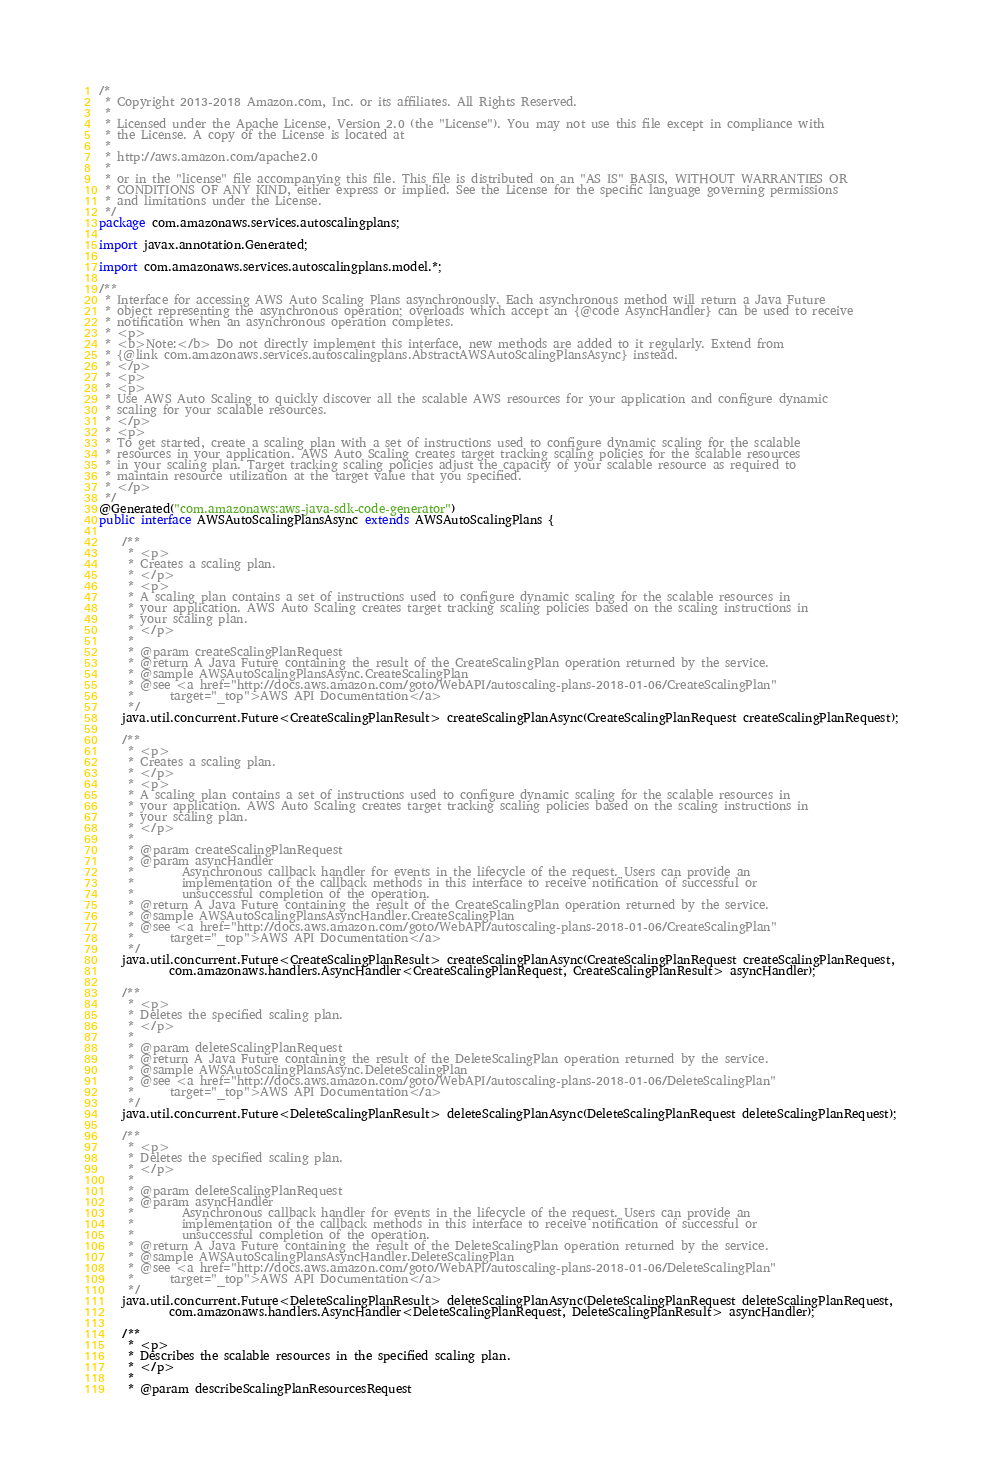<code> <loc_0><loc_0><loc_500><loc_500><_Java_>/*
 * Copyright 2013-2018 Amazon.com, Inc. or its affiliates. All Rights Reserved.
 * 
 * Licensed under the Apache License, Version 2.0 (the "License"). You may not use this file except in compliance with
 * the License. A copy of the License is located at
 * 
 * http://aws.amazon.com/apache2.0
 * 
 * or in the "license" file accompanying this file. This file is distributed on an "AS IS" BASIS, WITHOUT WARRANTIES OR
 * CONDITIONS OF ANY KIND, either express or implied. See the License for the specific language governing permissions
 * and limitations under the License.
 */
package com.amazonaws.services.autoscalingplans;

import javax.annotation.Generated;

import com.amazonaws.services.autoscalingplans.model.*;

/**
 * Interface for accessing AWS Auto Scaling Plans asynchronously. Each asynchronous method will return a Java Future
 * object representing the asynchronous operation; overloads which accept an {@code AsyncHandler} can be used to receive
 * notification when an asynchronous operation completes.
 * <p>
 * <b>Note:</b> Do not directly implement this interface, new methods are added to it regularly. Extend from
 * {@link com.amazonaws.services.autoscalingplans.AbstractAWSAutoScalingPlansAsync} instead.
 * </p>
 * <p>
 * <p>
 * Use AWS Auto Scaling to quickly discover all the scalable AWS resources for your application and configure dynamic
 * scaling for your scalable resources.
 * </p>
 * <p>
 * To get started, create a scaling plan with a set of instructions used to configure dynamic scaling for the scalable
 * resources in your application. AWS Auto Scaling creates target tracking scaling policies for the scalable resources
 * in your scaling plan. Target tracking scaling policies adjust the capacity of your scalable resource as required to
 * maintain resource utilization at the target value that you specified.
 * </p>
 */
@Generated("com.amazonaws:aws-java-sdk-code-generator")
public interface AWSAutoScalingPlansAsync extends AWSAutoScalingPlans {

    /**
     * <p>
     * Creates a scaling plan.
     * </p>
     * <p>
     * A scaling plan contains a set of instructions used to configure dynamic scaling for the scalable resources in
     * your application. AWS Auto Scaling creates target tracking scaling policies based on the scaling instructions in
     * your scaling plan.
     * </p>
     * 
     * @param createScalingPlanRequest
     * @return A Java Future containing the result of the CreateScalingPlan operation returned by the service.
     * @sample AWSAutoScalingPlansAsync.CreateScalingPlan
     * @see <a href="http://docs.aws.amazon.com/goto/WebAPI/autoscaling-plans-2018-01-06/CreateScalingPlan"
     *      target="_top">AWS API Documentation</a>
     */
    java.util.concurrent.Future<CreateScalingPlanResult> createScalingPlanAsync(CreateScalingPlanRequest createScalingPlanRequest);

    /**
     * <p>
     * Creates a scaling plan.
     * </p>
     * <p>
     * A scaling plan contains a set of instructions used to configure dynamic scaling for the scalable resources in
     * your application. AWS Auto Scaling creates target tracking scaling policies based on the scaling instructions in
     * your scaling plan.
     * </p>
     * 
     * @param createScalingPlanRequest
     * @param asyncHandler
     *        Asynchronous callback handler for events in the lifecycle of the request. Users can provide an
     *        implementation of the callback methods in this interface to receive notification of successful or
     *        unsuccessful completion of the operation.
     * @return A Java Future containing the result of the CreateScalingPlan operation returned by the service.
     * @sample AWSAutoScalingPlansAsyncHandler.CreateScalingPlan
     * @see <a href="http://docs.aws.amazon.com/goto/WebAPI/autoscaling-plans-2018-01-06/CreateScalingPlan"
     *      target="_top">AWS API Documentation</a>
     */
    java.util.concurrent.Future<CreateScalingPlanResult> createScalingPlanAsync(CreateScalingPlanRequest createScalingPlanRequest,
            com.amazonaws.handlers.AsyncHandler<CreateScalingPlanRequest, CreateScalingPlanResult> asyncHandler);

    /**
     * <p>
     * Deletes the specified scaling plan.
     * </p>
     * 
     * @param deleteScalingPlanRequest
     * @return A Java Future containing the result of the DeleteScalingPlan operation returned by the service.
     * @sample AWSAutoScalingPlansAsync.DeleteScalingPlan
     * @see <a href="http://docs.aws.amazon.com/goto/WebAPI/autoscaling-plans-2018-01-06/DeleteScalingPlan"
     *      target="_top">AWS API Documentation</a>
     */
    java.util.concurrent.Future<DeleteScalingPlanResult> deleteScalingPlanAsync(DeleteScalingPlanRequest deleteScalingPlanRequest);

    /**
     * <p>
     * Deletes the specified scaling plan.
     * </p>
     * 
     * @param deleteScalingPlanRequest
     * @param asyncHandler
     *        Asynchronous callback handler for events in the lifecycle of the request. Users can provide an
     *        implementation of the callback methods in this interface to receive notification of successful or
     *        unsuccessful completion of the operation.
     * @return A Java Future containing the result of the DeleteScalingPlan operation returned by the service.
     * @sample AWSAutoScalingPlansAsyncHandler.DeleteScalingPlan
     * @see <a href="http://docs.aws.amazon.com/goto/WebAPI/autoscaling-plans-2018-01-06/DeleteScalingPlan"
     *      target="_top">AWS API Documentation</a>
     */
    java.util.concurrent.Future<DeleteScalingPlanResult> deleteScalingPlanAsync(DeleteScalingPlanRequest deleteScalingPlanRequest,
            com.amazonaws.handlers.AsyncHandler<DeleteScalingPlanRequest, DeleteScalingPlanResult> asyncHandler);

    /**
     * <p>
     * Describes the scalable resources in the specified scaling plan.
     * </p>
     * 
     * @param describeScalingPlanResourcesRequest</code> 